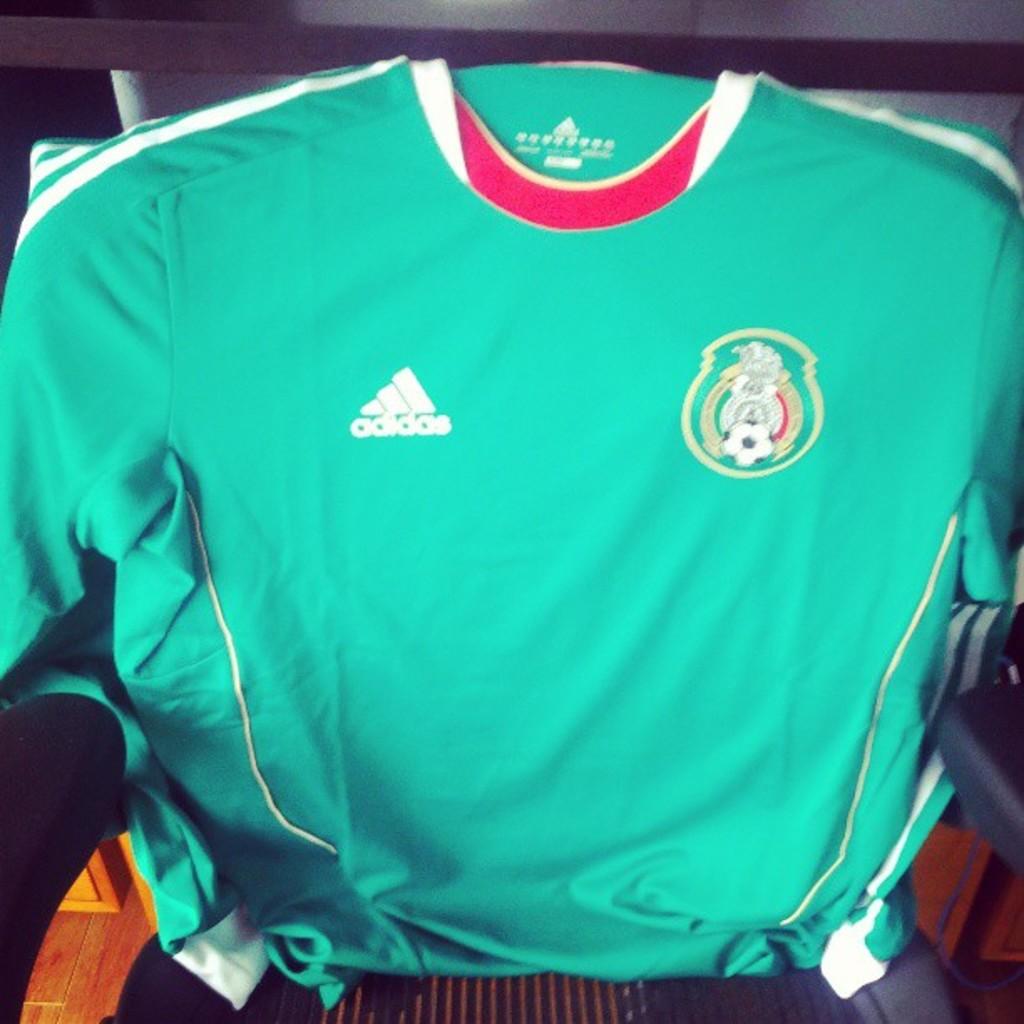What kind of sport is this for?
Your response must be concise. Soccer. What does the logo say under it on the blue shirt?
Provide a succinct answer. Adidas. 